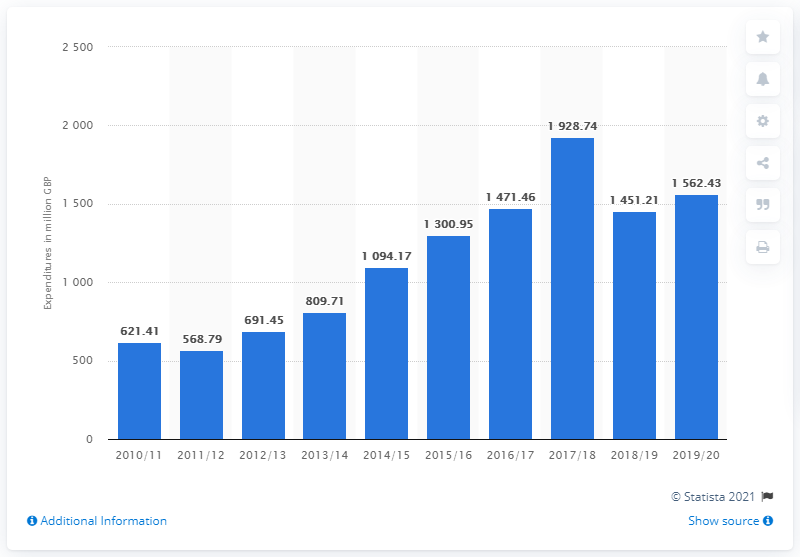Point out several critical features in this image. The total transfer expenditure for the 2017/2018 season was £1928.74. 